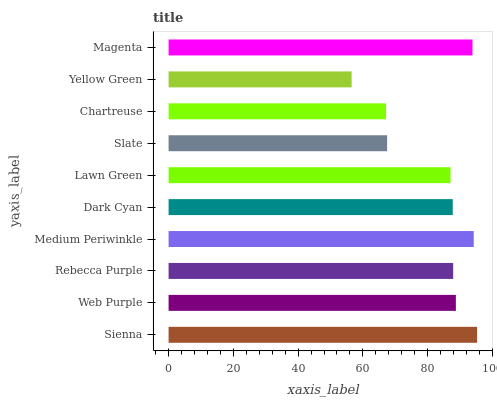Is Yellow Green the minimum?
Answer yes or no. Yes. Is Sienna the maximum?
Answer yes or no. Yes. Is Web Purple the minimum?
Answer yes or no. No. Is Web Purple the maximum?
Answer yes or no. No. Is Sienna greater than Web Purple?
Answer yes or no. Yes. Is Web Purple less than Sienna?
Answer yes or no. Yes. Is Web Purple greater than Sienna?
Answer yes or no. No. Is Sienna less than Web Purple?
Answer yes or no. No. Is Rebecca Purple the high median?
Answer yes or no. Yes. Is Dark Cyan the low median?
Answer yes or no. Yes. Is Dark Cyan the high median?
Answer yes or no. No. Is Web Purple the low median?
Answer yes or no. No. 